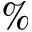Convert formula to latex. <formula><loc_0><loc_0><loc_500><loc_500>\%</formula> 